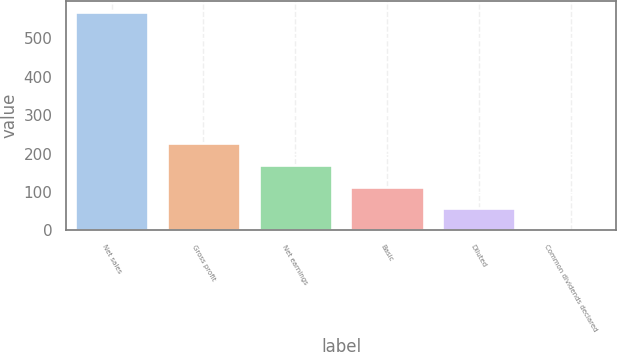<chart> <loc_0><loc_0><loc_500><loc_500><bar_chart><fcel>Net sales<fcel>Gross profit<fcel>Net earnings<fcel>Basic<fcel>Diluted<fcel>Common dividends declared<nl><fcel>569.9<fcel>228.06<fcel>171.09<fcel>114.12<fcel>57.15<fcel>0.18<nl></chart> 